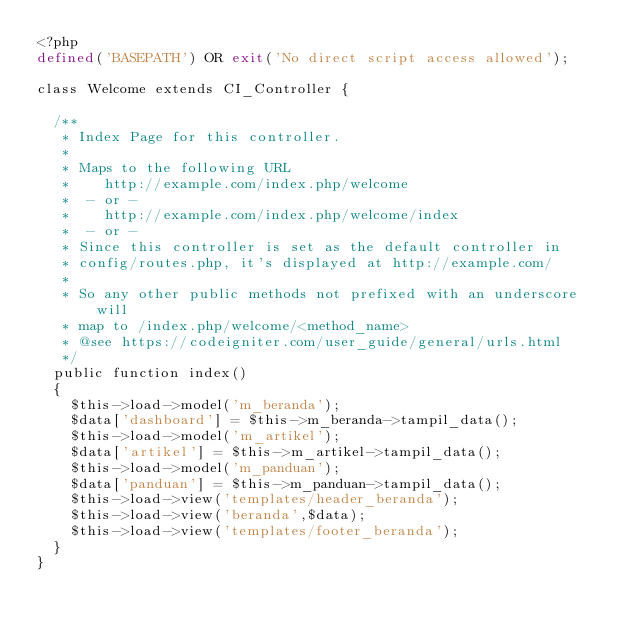Convert code to text. <code><loc_0><loc_0><loc_500><loc_500><_PHP_><?php
defined('BASEPATH') OR exit('No direct script access allowed');

class Welcome extends CI_Controller {

	/**
	 * Index Page for this controller.
	 *
	 * Maps to the following URL
	 * 		http://example.com/index.php/welcome
	 *	- or -
	 * 		http://example.com/index.php/welcome/index
	 *	- or -
	 * Since this controller is set as the default controller in
	 * config/routes.php, it's displayed at http://example.com/
	 *
	 * So any other public methods not prefixed with an underscore will
	 * map to /index.php/welcome/<method_name>
	 * @see https://codeigniter.com/user_guide/general/urls.html
	 */
	public function index()
	{
		$this->load->model('m_beranda');
		$data['dashboard'] = $this->m_beranda->tampil_data();
		$this->load->model('m_artikel');
		$data['artikel'] = $this->m_artikel->tampil_data();
		$this->load->model('m_panduan');
		$data['panduan'] = $this->m_panduan->tampil_data();
		$this->load->view('templates/header_beranda');
		$this->load->view('beranda',$data);
		$this->load->view('templates/footer_beranda');
	}
}
</code> 